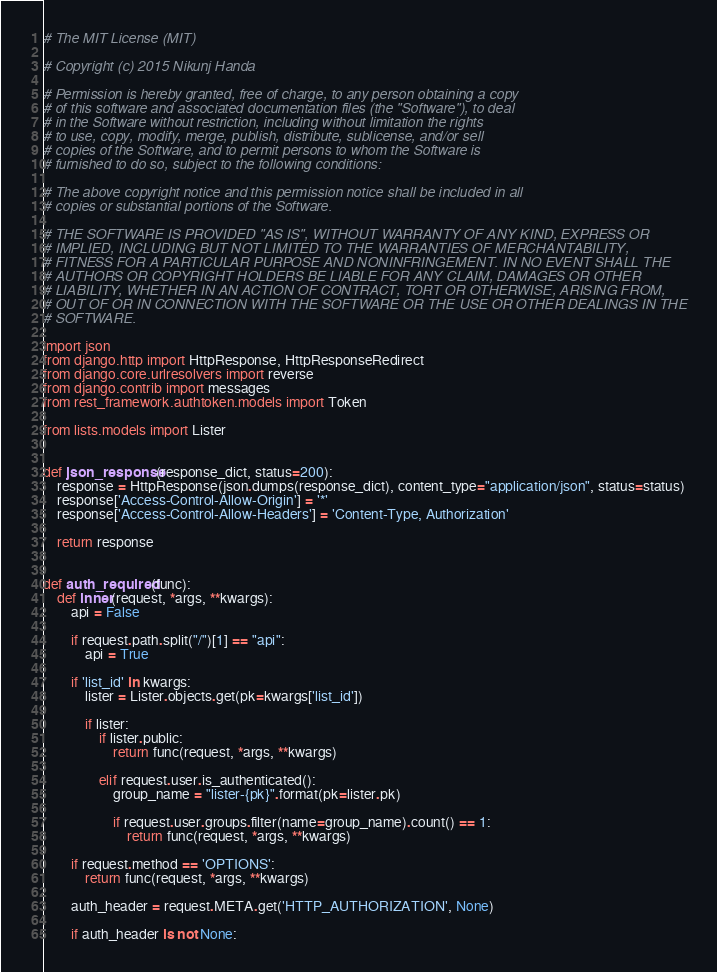Convert code to text. <code><loc_0><loc_0><loc_500><loc_500><_Python_># The MIT License (MIT)

# Copyright (c) 2015 Nikunj Handa

# Permission is hereby granted, free of charge, to any person obtaining a copy
# of this software and associated documentation files (the "Software"), to deal
# in the Software without restriction, including without limitation the rights
# to use, copy, modify, merge, publish, distribute, sublicense, and/or sell
# copies of the Software, and to permit persons to whom the Software is
# furnished to do so, subject to the following conditions:

# The above copyright notice and this permission notice shall be included in all
# copies or substantial portions of the Software.

# THE SOFTWARE IS PROVIDED "AS IS", WITHOUT WARRANTY OF ANY KIND, EXPRESS OR
# IMPLIED, INCLUDING BUT NOT LIMITED TO THE WARRANTIES OF MERCHANTABILITY,
# FITNESS FOR A PARTICULAR PURPOSE AND NONINFRINGEMENT. IN NO EVENT SHALL THE
# AUTHORS OR COPYRIGHT HOLDERS BE LIABLE FOR ANY CLAIM, DAMAGES OR OTHER
# LIABILITY, WHETHER IN AN ACTION OF CONTRACT, TORT OR OTHERWISE, ARISING FROM,
# OUT OF OR IN CONNECTION WITH THE SOFTWARE OR THE USE OR OTHER DEALINGS IN THE
# SOFTWARE.

import json
from django.http import HttpResponse, HttpResponseRedirect
from django.core.urlresolvers import reverse
from django.contrib import messages
from rest_framework.authtoken.models import Token

from lists.models import Lister


def json_response(response_dict, status=200):
    response = HttpResponse(json.dumps(response_dict), content_type="application/json", status=status)
    response['Access-Control-Allow-Origin'] = '*'
    response['Access-Control-Allow-Headers'] = 'Content-Type, Authorization'

    return response


def auth_required(func):
    def inner(request, *args, **kwargs):
        api = False

        if request.path.split("/")[1] == "api":
            api = True

        if 'list_id' in kwargs:
            lister = Lister.objects.get(pk=kwargs['list_id'])

            if lister:
                if lister.public:
                    return func(request, *args, **kwargs)

                elif request.user.is_authenticated():
                    group_name = "lister-{pk}".format(pk=lister.pk)

                    if request.user.groups.filter(name=group_name).count() == 1:
                        return func(request, *args, **kwargs)

        if request.method == 'OPTIONS':
            return func(request, *args, **kwargs)

        auth_header = request.META.get('HTTP_AUTHORIZATION', None)

        if auth_header is not None:</code> 